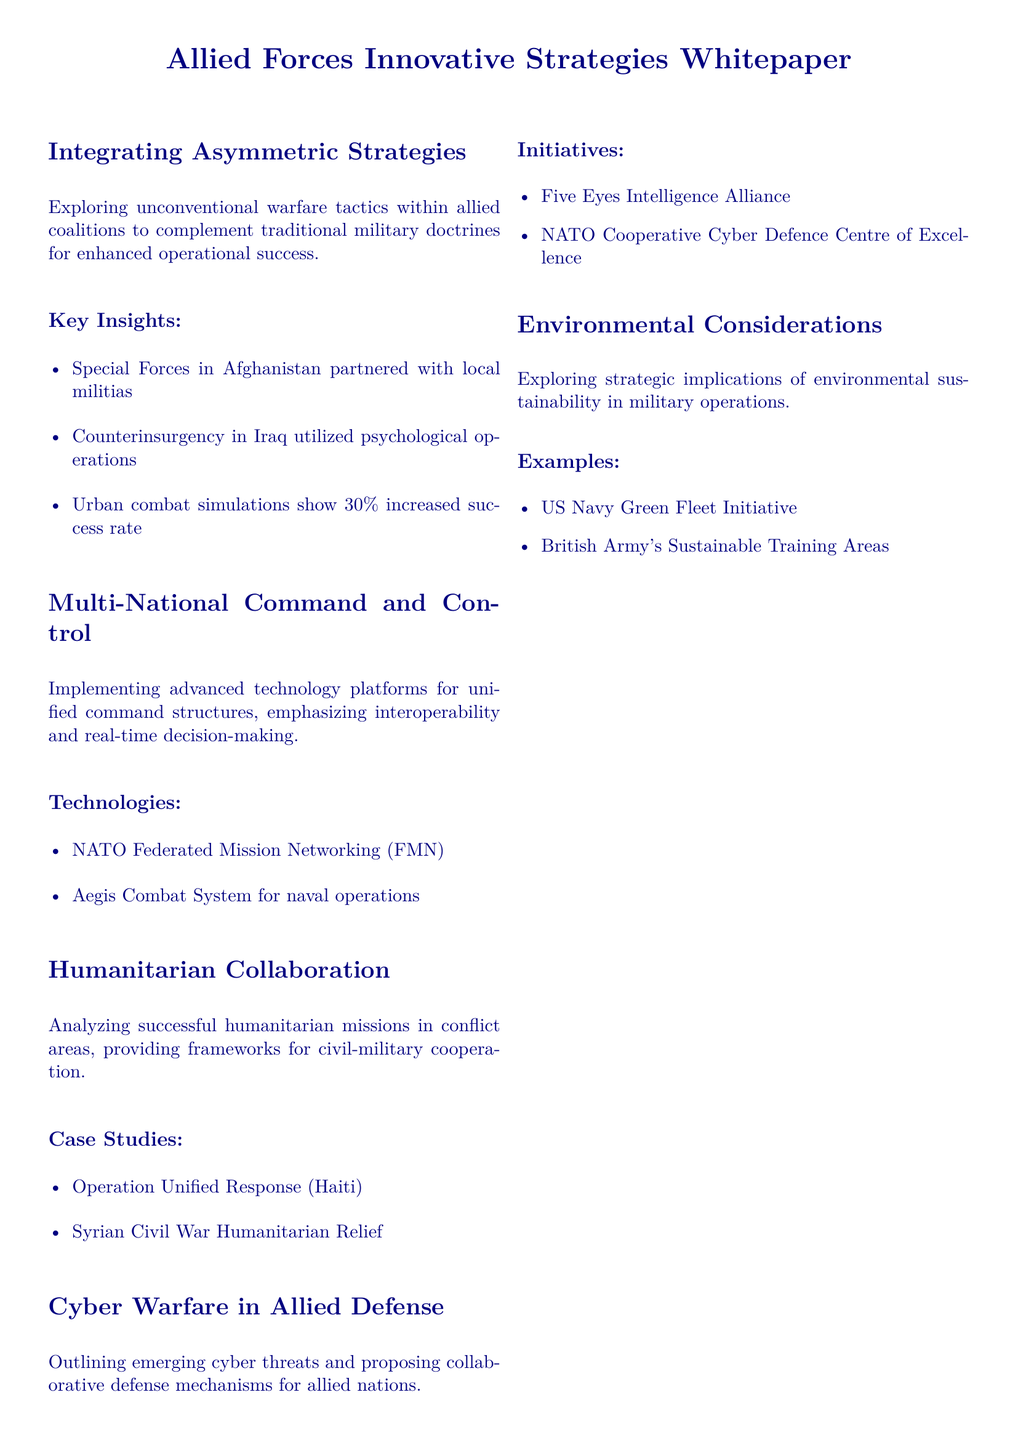What is the focus of the whitepaper? The whitepaper focuses on integrating innovative strategies across multiple domains for allied forces.
Answer: Integrating innovative strategies across multiple domains What percentage increase in success rate was shown in urban combat simulations? The document states that urban combat simulations show a 30% increased success rate.
Answer: 30% What technology is associated with naval operations? The document mentions the Aegis Combat System for naval operations.
Answer: Aegis Combat System Which operation is noted in the case studies for humanitarian collaboration? The case studies include Operation Unified Response (Haiti).
Answer: Operation Unified Response (Haiti) What initiative is part of the cyber warfare defense mechanisms? The Five Eyes Intelligence Alliance is mentioned as part of the initiatives in cyber warfare.
Answer: Five Eyes Intelligence Alliance What is the recommendation related to training modules? A recommendation is to incorporate asymmetrical training modules into coalition exercises.
Answer: Incorporate asymmetrical training modules What is the strategic vision stated in the document? The strategic vision emphasizes creating a more adaptable and effective coalition force.
Answer: Create a more adaptable and effective coalition force Which initiative aims at environmental sustainability in military operations? The US Navy Green Fleet Initiative is an example of environmental sustainability in military operations.
Answer: US Navy Green Fleet Initiative What type of document is this? The document is a whitepaper.
Answer: Whitepaper 